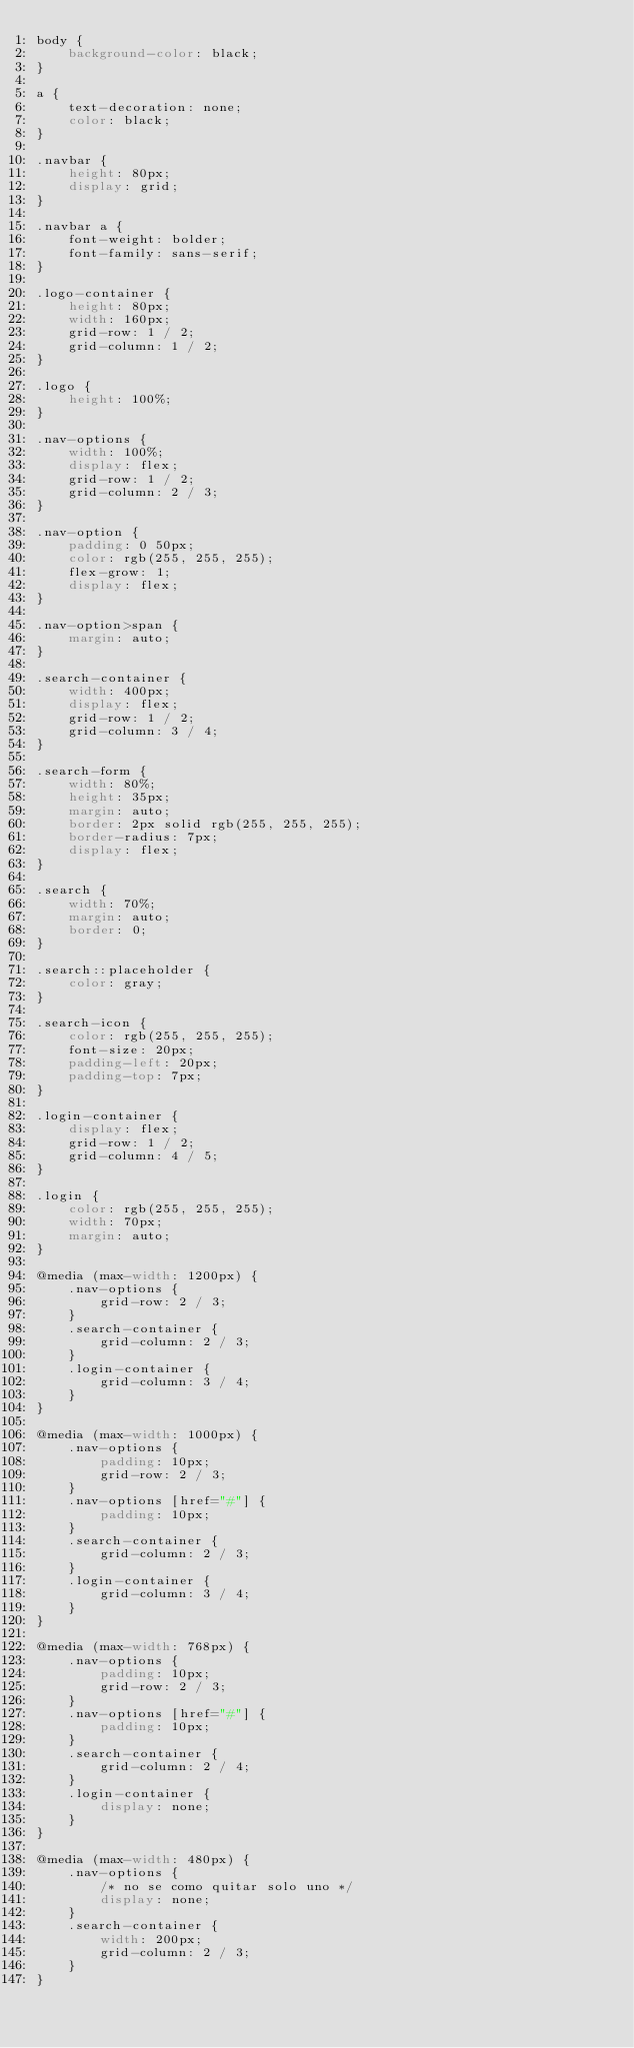<code> <loc_0><loc_0><loc_500><loc_500><_CSS_>body {
    background-color: black;
}

a {
    text-decoration: none;
    color: black;
}

.navbar {
    height: 80px;
    display: grid;
}

.navbar a {
    font-weight: bolder;
    font-family: sans-serif;
}

.logo-container {
    height: 80px;
    width: 160px;
    grid-row: 1 / 2;
    grid-column: 1 / 2;
}

.logo {
    height: 100%;
}

.nav-options {
    width: 100%;
    display: flex;
    grid-row: 1 / 2;
    grid-column: 2 / 3;
}

.nav-option {
    padding: 0 50px;
    color: rgb(255, 255, 255);
    flex-grow: 1;
    display: flex;
}

.nav-option>span {
    margin: auto;
}

.search-container {
    width: 400px;
    display: flex;
    grid-row: 1 / 2;
    grid-column: 3 / 4;
}

.search-form {
    width: 80%;
    height: 35px;
    margin: auto;
    border: 2px solid rgb(255, 255, 255);
    border-radius: 7px;
    display: flex;
}

.search {
    width: 70%;
    margin: auto;
    border: 0;
}

.search::placeholder {
    color: gray;
}

.search-icon {
    color: rgb(255, 255, 255);
    font-size: 20px;
    padding-left: 20px;
    padding-top: 7px;
}

.login-container {
    display: flex;
    grid-row: 1 / 2;
    grid-column: 4 / 5;
}

.login {
    color: rgb(255, 255, 255);
    width: 70px;
    margin: auto;
}

@media (max-width: 1200px) {
    .nav-options {
        grid-row: 2 / 3;
    }
    .search-container {
        grid-column: 2 / 3;
    }
    .login-container {
        grid-column: 3 / 4;
    }
}

@media (max-width: 1000px) {
    .nav-options {
        padding: 10px;
        grid-row: 2 / 3;
    }
    .nav-options [href="#"] {
        padding: 10px;
    }
    .search-container {
        grid-column: 2 / 3;
    }
    .login-container {
        grid-column: 3 / 4;
    }
}

@media (max-width: 768px) {
    .nav-options {
        padding: 10px;
        grid-row: 2 / 3;
    }
    .nav-options [href="#"] {
        padding: 10px;
    }
    .search-container {
        grid-column: 2 / 4;
    }
    .login-container {
        display: none;
    }
}

@media (max-width: 480px) {
    .nav-options {
        /* no se como quitar solo uno */
        display: none;
    }
    .search-container {
        width: 200px;
        grid-column: 2 / 3;
    }
}</code> 